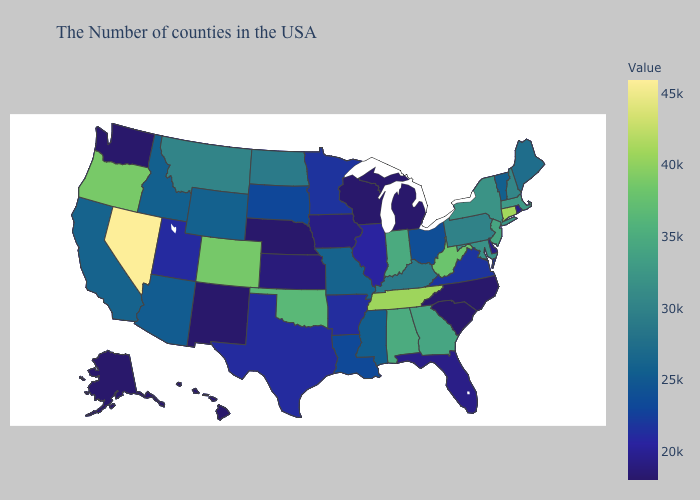Among the states that border Nebraska , which have the highest value?
Give a very brief answer. Colorado. Which states have the highest value in the USA?
Be succinct. Nevada. Which states have the lowest value in the South?
Keep it brief. North Carolina, South Carolina. Does Illinois have the highest value in the USA?
Short answer required. No. 